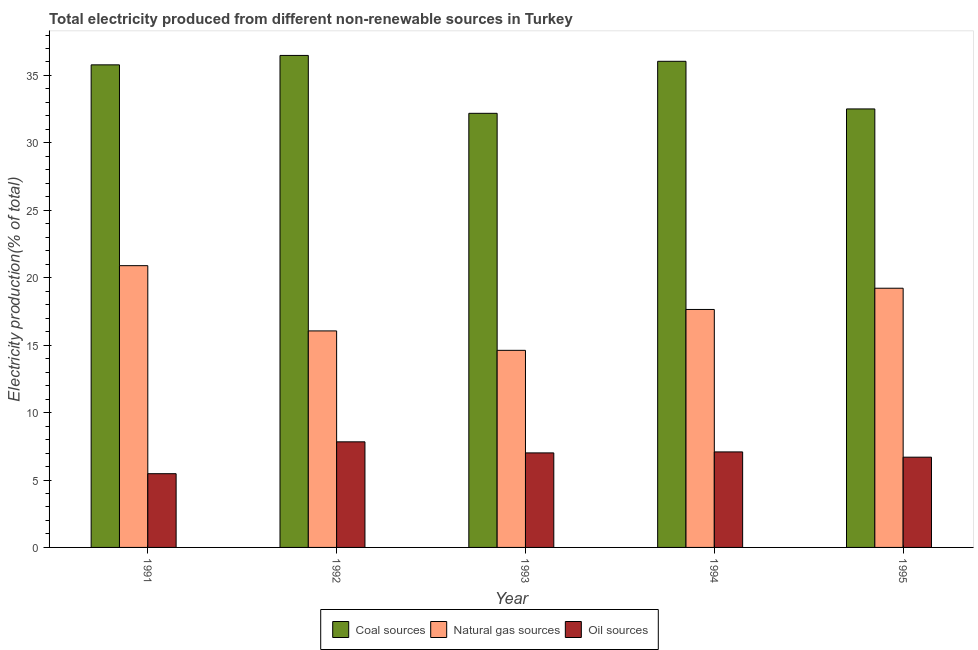How many different coloured bars are there?
Give a very brief answer. 3. Are the number of bars on each tick of the X-axis equal?
Your response must be concise. Yes. How many bars are there on the 3rd tick from the left?
Make the answer very short. 3. How many bars are there on the 3rd tick from the right?
Your answer should be very brief. 3. What is the percentage of electricity produced by oil sources in 1993?
Offer a terse response. 7.01. Across all years, what is the maximum percentage of electricity produced by natural gas?
Offer a very short reply. 20.9. Across all years, what is the minimum percentage of electricity produced by coal?
Your answer should be compact. 32.19. In which year was the percentage of electricity produced by oil sources maximum?
Offer a terse response. 1992. What is the total percentage of electricity produced by natural gas in the graph?
Your response must be concise. 88.44. What is the difference between the percentage of electricity produced by oil sources in 1991 and that in 1992?
Make the answer very short. -2.36. What is the difference between the percentage of electricity produced by oil sources in 1991 and the percentage of electricity produced by coal in 1995?
Provide a succinct answer. -1.22. What is the average percentage of electricity produced by coal per year?
Provide a short and direct response. 34.61. In the year 1995, what is the difference between the percentage of electricity produced by natural gas and percentage of electricity produced by oil sources?
Provide a succinct answer. 0. In how many years, is the percentage of electricity produced by coal greater than 12 %?
Keep it short and to the point. 5. What is the ratio of the percentage of electricity produced by oil sources in 1991 to that in 1994?
Make the answer very short. 0.77. Is the difference between the percentage of electricity produced by oil sources in 1992 and 1994 greater than the difference between the percentage of electricity produced by natural gas in 1992 and 1994?
Provide a short and direct response. No. What is the difference between the highest and the second highest percentage of electricity produced by oil sources?
Give a very brief answer. 0.75. What is the difference between the highest and the lowest percentage of electricity produced by coal?
Provide a succinct answer. 4.29. Is the sum of the percentage of electricity produced by coal in 1991 and 1995 greater than the maximum percentage of electricity produced by oil sources across all years?
Make the answer very short. Yes. What does the 3rd bar from the left in 1993 represents?
Give a very brief answer. Oil sources. What does the 1st bar from the right in 1994 represents?
Your response must be concise. Oil sources. How many bars are there?
Your answer should be very brief. 15. Are all the bars in the graph horizontal?
Make the answer very short. No. How many years are there in the graph?
Your answer should be very brief. 5. What is the difference between two consecutive major ticks on the Y-axis?
Keep it short and to the point. 5. Does the graph contain grids?
Provide a succinct answer. No. Where does the legend appear in the graph?
Offer a very short reply. Bottom center. How many legend labels are there?
Give a very brief answer. 3. What is the title of the graph?
Ensure brevity in your answer.  Total electricity produced from different non-renewable sources in Turkey. What is the label or title of the X-axis?
Offer a terse response. Year. What is the Electricity production(% of total) of Coal sources in 1991?
Keep it short and to the point. 35.79. What is the Electricity production(% of total) of Natural gas sources in 1991?
Keep it short and to the point. 20.9. What is the Electricity production(% of total) of Oil sources in 1991?
Make the answer very short. 5.47. What is the Electricity production(% of total) of Coal sources in 1992?
Give a very brief answer. 36.49. What is the Electricity production(% of total) of Natural gas sources in 1992?
Keep it short and to the point. 16.06. What is the Electricity production(% of total) in Oil sources in 1992?
Provide a short and direct response. 7.83. What is the Electricity production(% of total) of Coal sources in 1993?
Provide a short and direct response. 32.19. What is the Electricity production(% of total) in Natural gas sources in 1993?
Ensure brevity in your answer.  14.62. What is the Electricity production(% of total) of Oil sources in 1993?
Make the answer very short. 7.01. What is the Electricity production(% of total) in Coal sources in 1994?
Provide a short and direct response. 36.05. What is the Electricity production(% of total) of Natural gas sources in 1994?
Your answer should be very brief. 17.65. What is the Electricity production(% of total) of Oil sources in 1994?
Keep it short and to the point. 7.08. What is the Electricity production(% of total) in Coal sources in 1995?
Provide a short and direct response. 32.52. What is the Electricity production(% of total) in Natural gas sources in 1995?
Make the answer very short. 19.22. What is the Electricity production(% of total) of Oil sources in 1995?
Offer a very short reply. 6.69. Across all years, what is the maximum Electricity production(% of total) in Coal sources?
Make the answer very short. 36.49. Across all years, what is the maximum Electricity production(% of total) in Natural gas sources?
Provide a short and direct response. 20.9. Across all years, what is the maximum Electricity production(% of total) in Oil sources?
Offer a very short reply. 7.83. Across all years, what is the minimum Electricity production(% of total) in Coal sources?
Provide a succinct answer. 32.19. Across all years, what is the minimum Electricity production(% of total) in Natural gas sources?
Provide a succinct answer. 14.62. Across all years, what is the minimum Electricity production(% of total) of Oil sources?
Your response must be concise. 5.47. What is the total Electricity production(% of total) of Coal sources in the graph?
Your response must be concise. 173.04. What is the total Electricity production(% of total) of Natural gas sources in the graph?
Give a very brief answer. 88.44. What is the total Electricity production(% of total) of Oil sources in the graph?
Provide a short and direct response. 34.08. What is the difference between the Electricity production(% of total) of Coal sources in 1991 and that in 1992?
Offer a very short reply. -0.7. What is the difference between the Electricity production(% of total) in Natural gas sources in 1991 and that in 1992?
Your answer should be compact. 4.84. What is the difference between the Electricity production(% of total) in Oil sources in 1991 and that in 1992?
Keep it short and to the point. -2.36. What is the difference between the Electricity production(% of total) in Coal sources in 1991 and that in 1993?
Offer a terse response. 3.6. What is the difference between the Electricity production(% of total) in Natural gas sources in 1991 and that in 1993?
Your response must be concise. 6.28. What is the difference between the Electricity production(% of total) of Oil sources in 1991 and that in 1993?
Ensure brevity in your answer.  -1.54. What is the difference between the Electricity production(% of total) of Coal sources in 1991 and that in 1994?
Give a very brief answer. -0.26. What is the difference between the Electricity production(% of total) of Natural gas sources in 1991 and that in 1994?
Make the answer very short. 3.25. What is the difference between the Electricity production(% of total) in Oil sources in 1991 and that in 1994?
Offer a very short reply. -1.62. What is the difference between the Electricity production(% of total) of Coal sources in 1991 and that in 1995?
Provide a short and direct response. 3.27. What is the difference between the Electricity production(% of total) of Natural gas sources in 1991 and that in 1995?
Provide a succinct answer. 1.67. What is the difference between the Electricity production(% of total) of Oil sources in 1991 and that in 1995?
Make the answer very short. -1.22. What is the difference between the Electricity production(% of total) of Coal sources in 1992 and that in 1993?
Your response must be concise. 4.29. What is the difference between the Electricity production(% of total) in Natural gas sources in 1992 and that in 1993?
Keep it short and to the point. 1.44. What is the difference between the Electricity production(% of total) in Oil sources in 1992 and that in 1993?
Provide a short and direct response. 0.82. What is the difference between the Electricity production(% of total) of Coal sources in 1992 and that in 1994?
Provide a succinct answer. 0.44. What is the difference between the Electricity production(% of total) in Natural gas sources in 1992 and that in 1994?
Provide a succinct answer. -1.59. What is the difference between the Electricity production(% of total) of Oil sources in 1992 and that in 1994?
Give a very brief answer. 0.75. What is the difference between the Electricity production(% of total) of Coal sources in 1992 and that in 1995?
Your answer should be very brief. 3.97. What is the difference between the Electricity production(% of total) in Natural gas sources in 1992 and that in 1995?
Your answer should be compact. -3.17. What is the difference between the Electricity production(% of total) of Oil sources in 1992 and that in 1995?
Ensure brevity in your answer.  1.14. What is the difference between the Electricity production(% of total) of Coal sources in 1993 and that in 1994?
Offer a terse response. -3.86. What is the difference between the Electricity production(% of total) of Natural gas sources in 1993 and that in 1994?
Your response must be concise. -3.03. What is the difference between the Electricity production(% of total) of Oil sources in 1993 and that in 1994?
Provide a succinct answer. -0.07. What is the difference between the Electricity production(% of total) in Coal sources in 1993 and that in 1995?
Ensure brevity in your answer.  -0.33. What is the difference between the Electricity production(% of total) in Natural gas sources in 1993 and that in 1995?
Give a very brief answer. -4.61. What is the difference between the Electricity production(% of total) in Oil sources in 1993 and that in 1995?
Provide a succinct answer. 0.32. What is the difference between the Electricity production(% of total) of Coal sources in 1994 and that in 1995?
Offer a very short reply. 3.53. What is the difference between the Electricity production(% of total) of Natural gas sources in 1994 and that in 1995?
Provide a short and direct response. -1.57. What is the difference between the Electricity production(% of total) of Oil sources in 1994 and that in 1995?
Make the answer very short. 0.39. What is the difference between the Electricity production(% of total) of Coal sources in 1991 and the Electricity production(% of total) of Natural gas sources in 1992?
Your response must be concise. 19.73. What is the difference between the Electricity production(% of total) in Coal sources in 1991 and the Electricity production(% of total) in Oil sources in 1992?
Offer a very short reply. 27.96. What is the difference between the Electricity production(% of total) in Natural gas sources in 1991 and the Electricity production(% of total) in Oil sources in 1992?
Offer a very short reply. 13.07. What is the difference between the Electricity production(% of total) of Coal sources in 1991 and the Electricity production(% of total) of Natural gas sources in 1993?
Give a very brief answer. 21.17. What is the difference between the Electricity production(% of total) of Coal sources in 1991 and the Electricity production(% of total) of Oil sources in 1993?
Your answer should be very brief. 28.78. What is the difference between the Electricity production(% of total) in Natural gas sources in 1991 and the Electricity production(% of total) in Oil sources in 1993?
Make the answer very short. 13.89. What is the difference between the Electricity production(% of total) of Coal sources in 1991 and the Electricity production(% of total) of Natural gas sources in 1994?
Provide a short and direct response. 18.14. What is the difference between the Electricity production(% of total) in Coal sources in 1991 and the Electricity production(% of total) in Oil sources in 1994?
Your answer should be very brief. 28.7. What is the difference between the Electricity production(% of total) of Natural gas sources in 1991 and the Electricity production(% of total) of Oil sources in 1994?
Make the answer very short. 13.81. What is the difference between the Electricity production(% of total) of Coal sources in 1991 and the Electricity production(% of total) of Natural gas sources in 1995?
Offer a terse response. 16.57. What is the difference between the Electricity production(% of total) in Coal sources in 1991 and the Electricity production(% of total) in Oil sources in 1995?
Provide a succinct answer. 29.1. What is the difference between the Electricity production(% of total) in Natural gas sources in 1991 and the Electricity production(% of total) in Oil sources in 1995?
Ensure brevity in your answer.  14.2. What is the difference between the Electricity production(% of total) in Coal sources in 1992 and the Electricity production(% of total) in Natural gas sources in 1993?
Provide a succinct answer. 21.87. What is the difference between the Electricity production(% of total) in Coal sources in 1992 and the Electricity production(% of total) in Oil sources in 1993?
Make the answer very short. 29.48. What is the difference between the Electricity production(% of total) of Natural gas sources in 1992 and the Electricity production(% of total) of Oil sources in 1993?
Your response must be concise. 9.05. What is the difference between the Electricity production(% of total) of Coal sources in 1992 and the Electricity production(% of total) of Natural gas sources in 1994?
Your answer should be compact. 18.84. What is the difference between the Electricity production(% of total) of Coal sources in 1992 and the Electricity production(% of total) of Oil sources in 1994?
Keep it short and to the point. 29.4. What is the difference between the Electricity production(% of total) in Natural gas sources in 1992 and the Electricity production(% of total) in Oil sources in 1994?
Offer a very short reply. 8.97. What is the difference between the Electricity production(% of total) in Coal sources in 1992 and the Electricity production(% of total) in Natural gas sources in 1995?
Offer a terse response. 17.26. What is the difference between the Electricity production(% of total) of Coal sources in 1992 and the Electricity production(% of total) of Oil sources in 1995?
Give a very brief answer. 29.79. What is the difference between the Electricity production(% of total) in Natural gas sources in 1992 and the Electricity production(% of total) in Oil sources in 1995?
Keep it short and to the point. 9.36. What is the difference between the Electricity production(% of total) of Coal sources in 1993 and the Electricity production(% of total) of Natural gas sources in 1994?
Give a very brief answer. 14.55. What is the difference between the Electricity production(% of total) in Coal sources in 1993 and the Electricity production(% of total) in Oil sources in 1994?
Offer a very short reply. 25.11. What is the difference between the Electricity production(% of total) in Natural gas sources in 1993 and the Electricity production(% of total) in Oil sources in 1994?
Give a very brief answer. 7.53. What is the difference between the Electricity production(% of total) in Coal sources in 1993 and the Electricity production(% of total) in Natural gas sources in 1995?
Provide a succinct answer. 12.97. What is the difference between the Electricity production(% of total) in Coal sources in 1993 and the Electricity production(% of total) in Oil sources in 1995?
Give a very brief answer. 25.5. What is the difference between the Electricity production(% of total) of Natural gas sources in 1993 and the Electricity production(% of total) of Oil sources in 1995?
Your response must be concise. 7.92. What is the difference between the Electricity production(% of total) in Coal sources in 1994 and the Electricity production(% of total) in Natural gas sources in 1995?
Your answer should be compact. 16.83. What is the difference between the Electricity production(% of total) of Coal sources in 1994 and the Electricity production(% of total) of Oil sources in 1995?
Ensure brevity in your answer.  29.36. What is the difference between the Electricity production(% of total) of Natural gas sources in 1994 and the Electricity production(% of total) of Oil sources in 1995?
Keep it short and to the point. 10.96. What is the average Electricity production(% of total) in Coal sources per year?
Your response must be concise. 34.61. What is the average Electricity production(% of total) of Natural gas sources per year?
Give a very brief answer. 17.69. What is the average Electricity production(% of total) in Oil sources per year?
Offer a very short reply. 6.82. In the year 1991, what is the difference between the Electricity production(% of total) in Coal sources and Electricity production(% of total) in Natural gas sources?
Provide a succinct answer. 14.89. In the year 1991, what is the difference between the Electricity production(% of total) in Coal sources and Electricity production(% of total) in Oil sources?
Ensure brevity in your answer.  30.32. In the year 1991, what is the difference between the Electricity production(% of total) in Natural gas sources and Electricity production(% of total) in Oil sources?
Provide a short and direct response. 15.43. In the year 1992, what is the difference between the Electricity production(% of total) of Coal sources and Electricity production(% of total) of Natural gas sources?
Provide a short and direct response. 20.43. In the year 1992, what is the difference between the Electricity production(% of total) in Coal sources and Electricity production(% of total) in Oil sources?
Ensure brevity in your answer.  28.66. In the year 1992, what is the difference between the Electricity production(% of total) in Natural gas sources and Electricity production(% of total) in Oil sources?
Your answer should be very brief. 8.23. In the year 1993, what is the difference between the Electricity production(% of total) of Coal sources and Electricity production(% of total) of Natural gas sources?
Your answer should be very brief. 17.58. In the year 1993, what is the difference between the Electricity production(% of total) of Coal sources and Electricity production(% of total) of Oil sources?
Make the answer very short. 25.18. In the year 1993, what is the difference between the Electricity production(% of total) of Natural gas sources and Electricity production(% of total) of Oil sources?
Your answer should be compact. 7.61. In the year 1994, what is the difference between the Electricity production(% of total) in Coal sources and Electricity production(% of total) in Natural gas sources?
Give a very brief answer. 18.4. In the year 1994, what is the difference between the Electricity production(% of total) of Coal sources and Electricity production(% of total) of Oil sources?
Ensure brevity in your answer.  28.97. In the year 1994, what is the difference between the Electricity production(% of total) in Natural gas sources and Electricity production(% of total) in Oil sources?
Provide a succinct answer. 10.56. In the year 1995, what is the difference between the Electricity production(% of total) of Coal sources and Electricity production(% of total) of Natural gas sources?
Offer a terse response. 13.3. In the year 1995, what is the difference between the Electricity production(% of total) of Coal sources and Electricity production(% of total) of Oil sources?
Make the answer very short. 25.83. In the year 1995, what is the difference between the Electricity production(% of total) in Natural gas sources and Electricity production(% of total) in Oil sources?
Keep it short and to the point. 12.53. What is the ratio of the Electricity production(% of total) of Coal sources in 1991 to that in 1992?
Your response must be concise. 0.98. What is the ratio of the Electricity production(% of total) in Natural gas sources in 1991 to that in 1992?
Your response must be concise. 1.3. What is the ratio of the Electricity production(% of total) in Oil sources in 1991 to that in 1992?
Ensure brevity in your answer.  0.7. What is the ratio of the Electricity production(% of total) in Coal sources in 1991 to that in 1993?
Provide a succinct answer. 1.11. What is the ratio of the Electricity production(% of total) of Natural gas sources in 1991 to that in 1993?
Your answer should be very brief. 1.43. What is the ratio of the Electricity production(% of total) in Oil sources in 1991 to that in 1993?
Offer a very short reply. 0.78. What is the ratio of the Electricity production(% of total) in Natural gas sources in 1991 to that in 1994?
Offer a terse response. 1.18. What is the ratio of the Electricity production(% of total) of Oil sources in 1991 to that in 1994?
Offer a very short reply. 0.77. What is the ratio of the Electricity production(% of total) of Coal sources in 1991 to that in 1995?
Offer a terse response. 1.1. What is the ratio of the Electricity production(% of total) in Natural gas sources in 1991 to that in 1995?
Your response must be concise. 1.09. What is the ratio of the Electricity production(% of total) of Oil sources in 1991 to that in 1995?
Your answer should be very brief. 0.82. What is the ratio of the Electricity production(% of total) in Coal sources in 1992 to that in 1993?
Your answer should be very brief. 1.13. What is the ratio of the Electricity production(% of total) of Natural gas sources in 1992 to that in 1993?
Give a very brief answer. 1.1. What is the ratio of the Electricity production(% of total) in Oil sources in 1992 to that in 1993?
Keep it short and to the point. 1.12. What is the ratio of the Electricity production(% of total) of Coal sources in 1992 to that in 1994?
Your answer should be compact. 1.01. What is the ratio of the Electricity production(% of total) in Natural gas sources in 1992 to that in 1994?
Offer a terse response. 0.91. What is the ratio of the Electricity production(% of total) in Oil sources in 1992 to that in 1994?
Make the answer very short. 1.11. What is the ratio of the Electricity production(% of total) of Coal sources in 1992 to that in 1995?
Make the answer very short. 1.12. What is the ratio of the Electricity production(% of total) in Natural gas sources in 1992 to that in 1995?
Your answer should be very brief. 0.84. What is the ratio of the Electricity production(% of total) in Oil sources in 1992 to that in 1995?
Your answer should be very brief. 1.17. What is the ratio of the Electricity production(% of total) of Coal sources in 1993 to that in 1994?
Give a very brief answer. 0.89. What is the ratio of the Electricity production(% of total) of Natural gas sources in 1993 to that in 1994?
Provide a succinct answer. 0.83. What is the ratio of the Electricity production(% of total) in Oil sources in 1993 to that in 1994?
Provide a short and direct response. 0.99. What is the ratio of the Electricity production(% of total) of Coal sources in 1993 to that in 1995?
Provide a succinct answer. 0.99. What is the ratio of the Electricity production(% of total) of Natural gas sources in 1993 to that in 1995?
Your response must be concise. 0.76. What is the ratio of the Electricity production(% of total) of Oil sources in 1993 to that in 1995?
Give a very brief answer. 1.05. What is the ratio of the Electricity production(% of total) in Coal sources in 1994 to that in 1995?
Give a very brief answer. 1.11. What is the ratio of the Electricity production(% of total) in Natural gas sources in 1994 to that in 1995?
Give a very brief answer. 0.92. What is the ratio of the Electricity production(% of total) in Oil sources in 1994 to that in 1995?
Offer a very short reply. 1.06. What is the difference between the highest and the second highest Electricity production(% of total) in Coal sources?
Ensure brevity in your answer.  0.44. What is the difference between the highest and the second highest Electricity production(% of total) of Natural gas sources?
Ensure brevity in your answer.  1.67. What is the difference between the highest and the second highest Electricity production(% of total) in Oil sources?
Offer a terse response. 0.75. What is the difference between the highest and the lowest Electricity production(% of total) of Coal sources?
Your answer should be compact. 4.29. What is the difference between the highest and the lowest Electricity production(% of total) in Natural gas sources?
Ensure brevity in your answer.  6.28. What is the difference between the highest and the lowest Electricity production(% of total) in Oil sources?
Offer a very short reply. 2.36. 